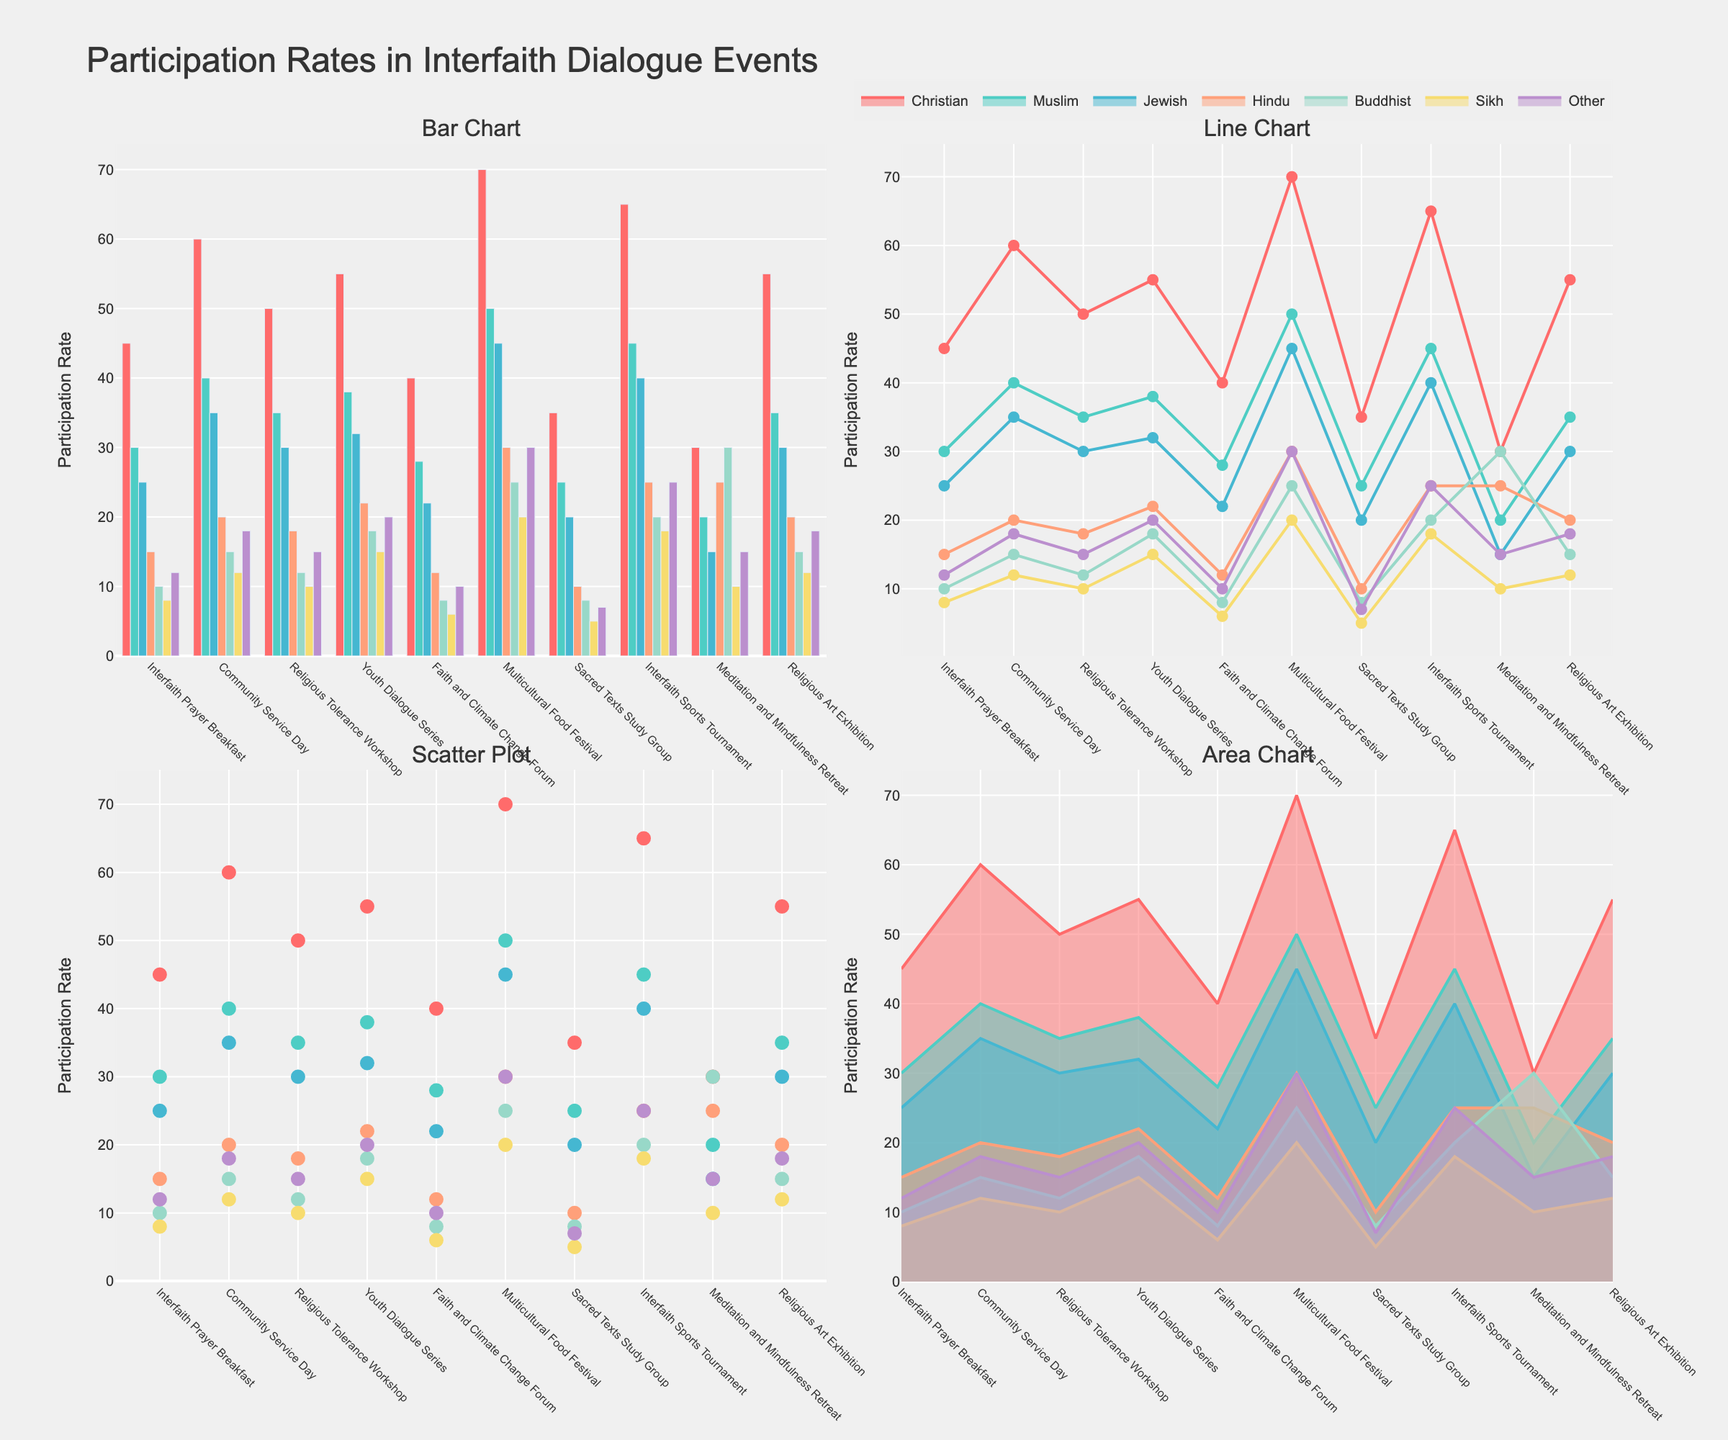How many interfaith dialogue events are shown in the figure? To find this, simply count the number of distinct events listed on the x-axis in any of the subplots.
Answer: 10 Which event had the highest participation rate among Christians in the bar chart? Look at the bar chart and identify the tallest bar corresponding to Christians' participation. This event is the Multicultural Food Festival.
Answer: Multicultural Food Festival In the line chart, what is the trend of Muslim participation across the events? Observe the line representing Muslim participation in the line chart. The line generally shows an increase in participation with some fluctuations.
Answer: Increasing with fluctuations Among Jewish participants, which two events had the same participation rate, according to the area chart? In the area chart, find the points where the Jewish participation line intersects horizontally at the same level. The points correspond to the Community Service Day and the Religious Art Exhibition.
Answer: Community Service Day, Religious Art Exhibition What is the average participation rate for Hindus across all events shown in the scatter plot? Find the participation rates for Hindus for each event in the scatter plot, sum them up, and divide by the number of events (10). (15 + 20 + 18 + 22 + 12 + 30 + 10 + 25 + 25 + 20) = 197; 197/10 = 19.7
Answer: 19.7 Which religious affiliation has the lowest variation in their participation rate across events, according to the line chart? Examine the line chart and identify the religion whose line is the most horizontal (least fluctuation). Buddhists have a relatively consistent line.
Answer: Buddhist Compare the participation rates between the Youth Dialogue Series and the Meditation and Mindfulness Retreat for Sikh participants. Which event had higher participation? In any of the subplots, locate the points for Youth Dialogue Series and Meditation and Mindfulness Retreat under Sikh participation and compare. The Youth Dialogue Series has higher participation (15 versus 10).
Answer: Youth Dialogue Series In the scatter plot, which religious group had the least participation in the Sacred Texts Study Group? Identify the point corresponding to the Sacred Texts Study Group for each religious affiliation in the scatter plot, and find the one with the smallest value. Sikhs had the least participation with 5.
Answer: Sikh Based on the bar chart, which event had the most balanced participation across all religious affiliations? Look for the bar group where the heights of the bars are more balanced compared to others. The Multicultural Food Festival has relatively balanced bars across affiliations.
Answer: Multicultural Food Festival 